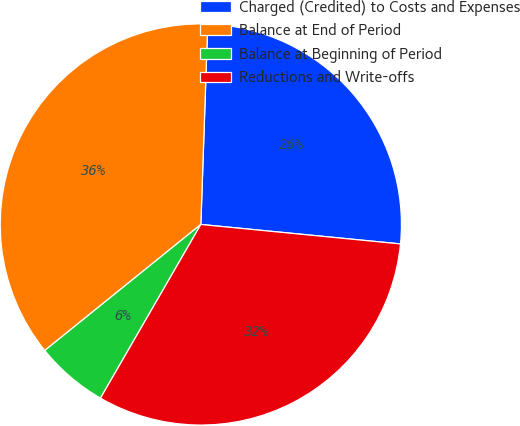Convert chart to OTSL. <chart><loc_0><loc_0><loc_500><loc_500><pie_chart><fcel>Charged (Credited) to Costs and Expenses<fcel>Balance at End of Period<fcel>Balance at Beginning of Period<fcel>Reductions and Write-offs<nl><fcel>26.0%<fcel>36.36%<fcel>5.85%<fcel>31.79%<nl></chart> 